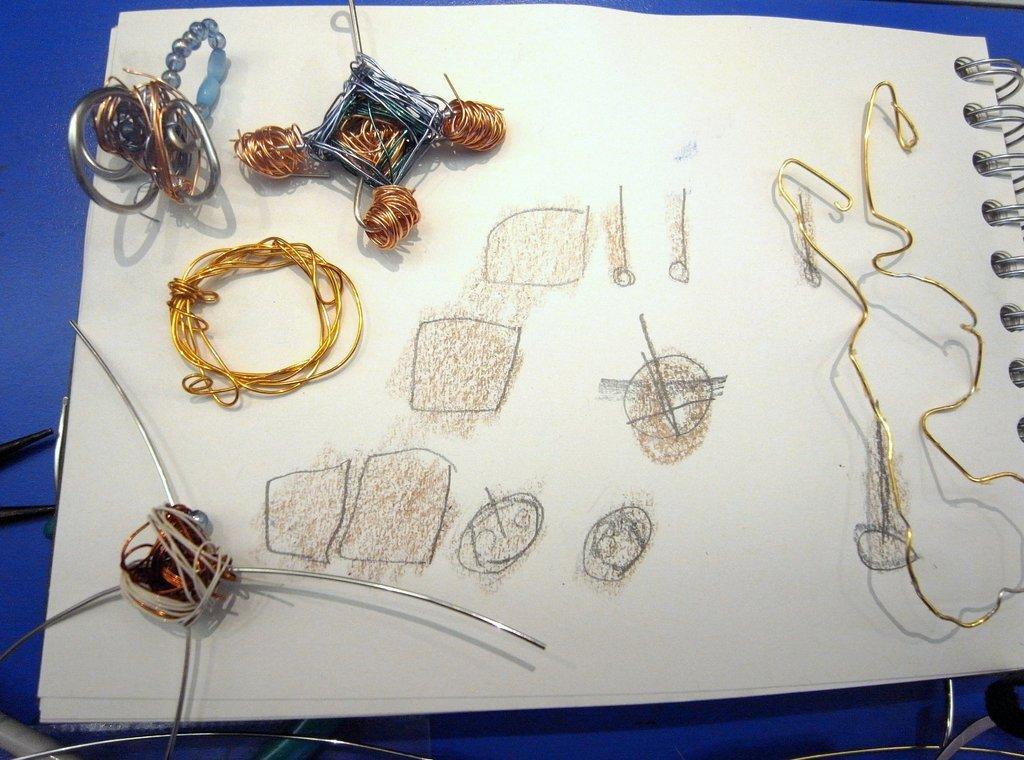Please provide a concise description of this image. In this image we can see a notepad on which some objects are placed and some shapes are drawn. 